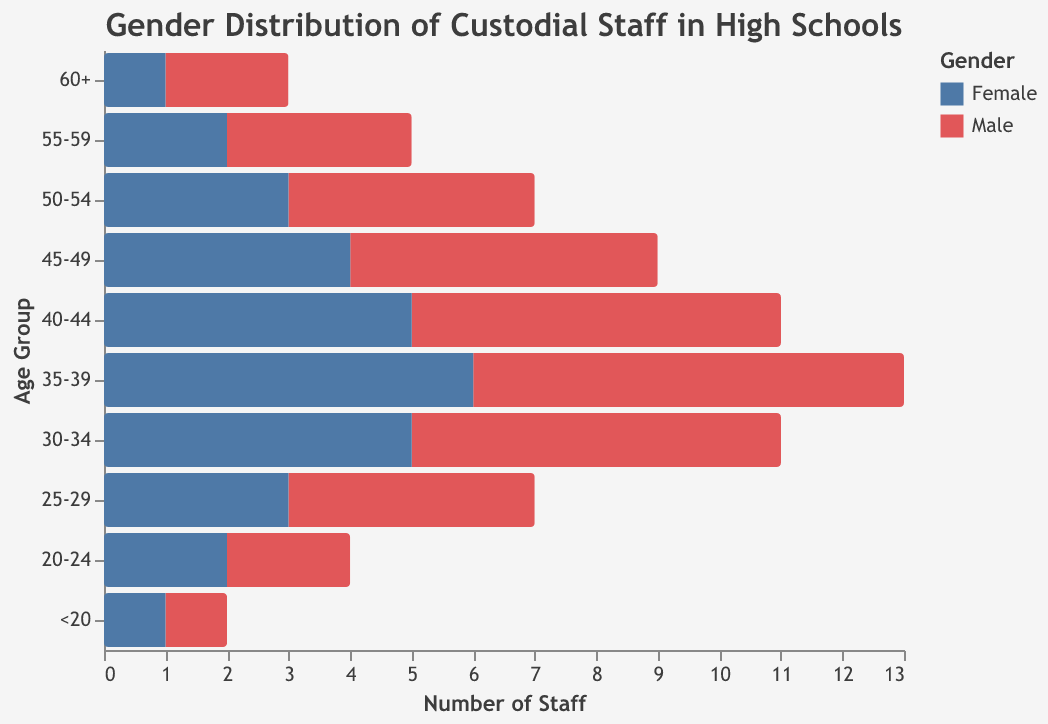What is the title of the figure? The title of the figure is located at the top and provides an overview of what the chart is about. This specific title is "Gender Distribution of Custodial Staff in High Schools".
Answer: Gender Distribution of Custodial Staff in High Schools Which age group has the highest number of male custodians? To find the highest number of male custodians, look at the bar chart for the "Male" category with the longest bar. In this case, it is in the "35-39" age group with a value of 7.
Answer: 35-39 What is the total number of female custodians in the "45-49" age group? For the "45-49" age group, look for the bar that represents female custodians, which has a negative value. The tooltip or bar label indicates it is -4. We take the magnitude which is 4.
Answer: 4 How does the number of male custodians in the "50-54" age group compare to the female custodians in the same age group? To compare, find the values for both male and female custodians. For the "50-54" age group, males have a value of 4, and females have -3. This shows there are more male custodians (4) than female custodians (3) in that age group.
Answer: More males How many total custodians are there in the "40-44" age group? Sum the absolute numbers of male and female custodians in the "40-44" age group. There are 6 males and 5 females. Hence, total custodians = 6 + 5 = 11.
Answer: 11 Which gender has a higher overall count in custodial staff across all age groups? Calculate the total number of custodians for each gender by summing the values for males and females across all age groups. Total males = 40; Total females = 32. Males have a higher overall count.
Answer: Males Is there an age group where the number of male and female custodians is exactly equal? Check each age group to see if the numbers for male and female are equal. There is no age group with equal numbers of male and female custodians.
Answer: No What is the range of age groups covered in the figure? The y-axis lists all the age groups mentioned in the dataset. They span from "<20" to "60+".
Answer: From "<20" to "60+" In which age group does the number of female custodians decrease compared to the previous age group? To identify the decrease, compare the number of female custodians from one age group to the next. From "45-49" to "50-54" the count of female custodians goes from -4 to -3.
Answer: 50-54 